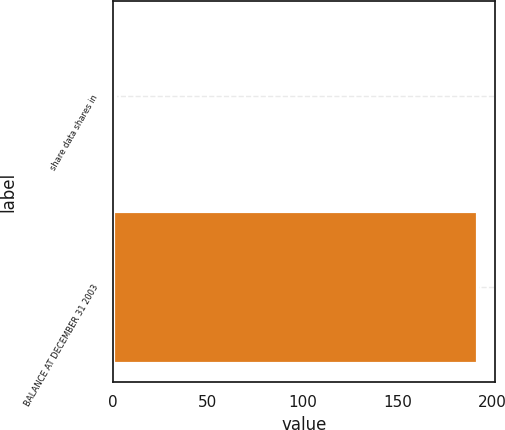<chart> <loc_0><loc_0><loc_500><loc_500><bar_chart><fcel>share data shares in<fcel>BALANCE AT DECEMBER 31 2003<nl><fcel>1<fcel>192<nl></chart> 